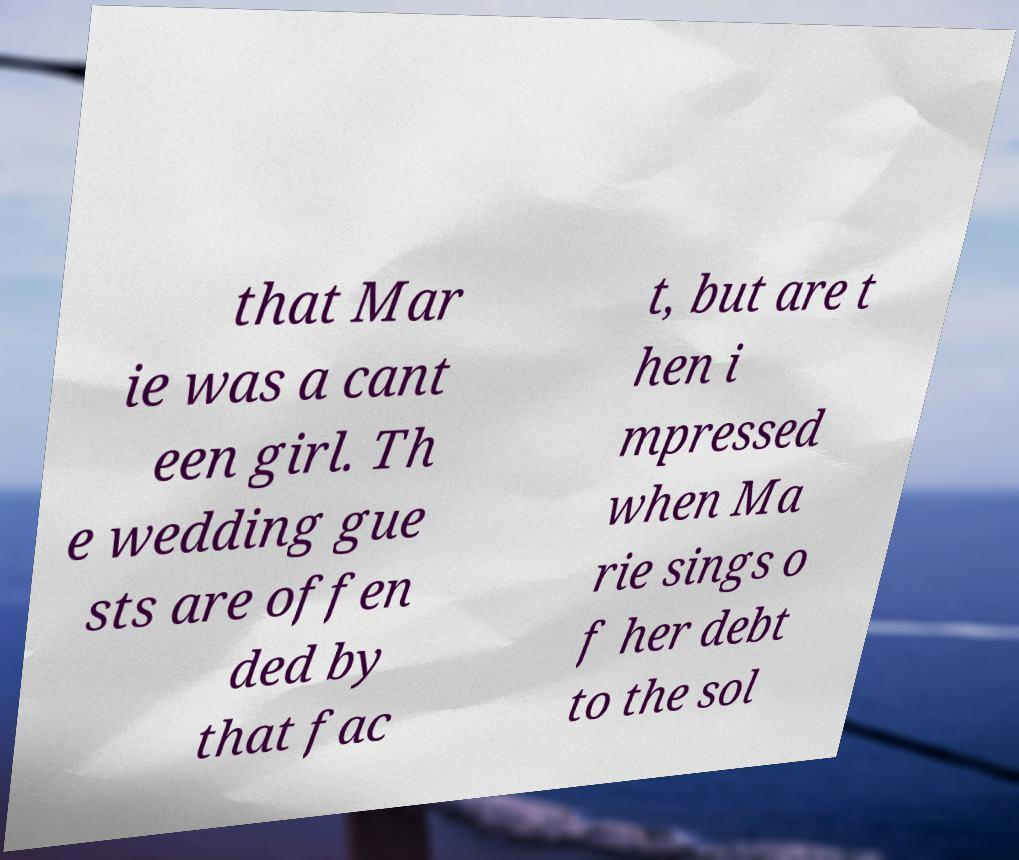Could you assist in decoding the text presented in this image and type it out clearly? that Mar ie was a cant een girl. Th e wedding gue sts are offen ded by that fac t, but are t hen i mpressed when Ma rie sings o f her debt to the sol 